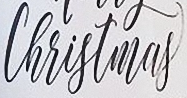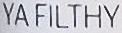Read the text content from these images in order, separated by a semicolon. Christmas; YAFILTHY 